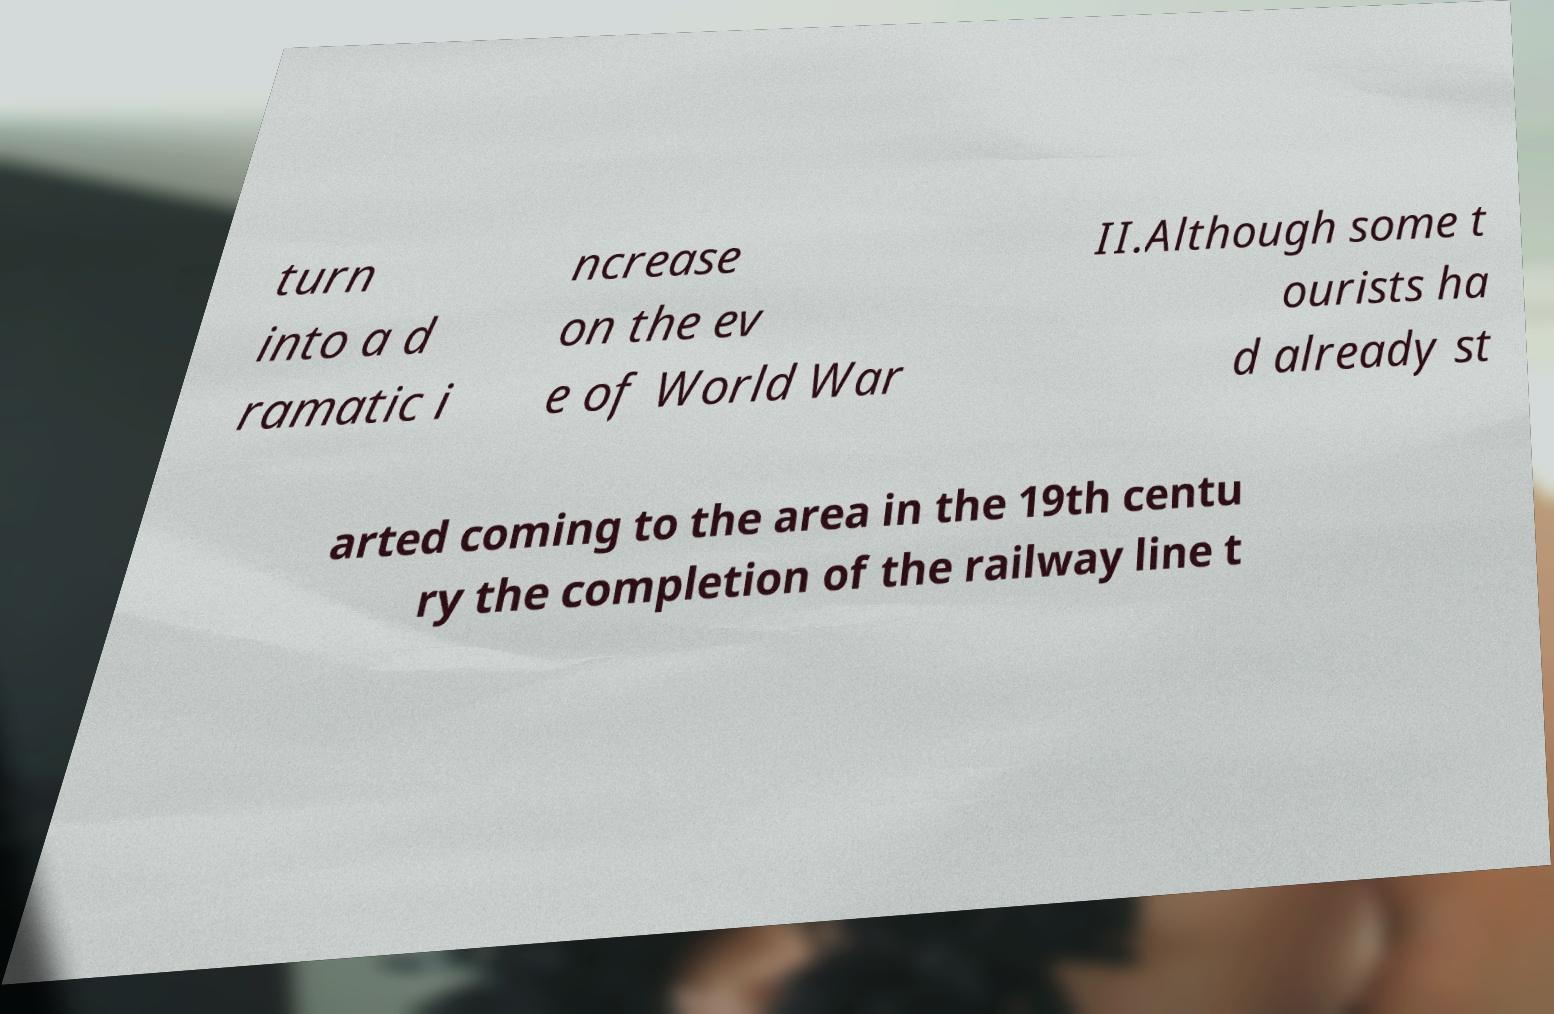Could you extract and type out the text from this image? turn into a d ramatic i ncrease on the ev e of World War II.Although some t ourists ha d already st arted coming to the area in the 19th centu ry the completion of the railway line t 